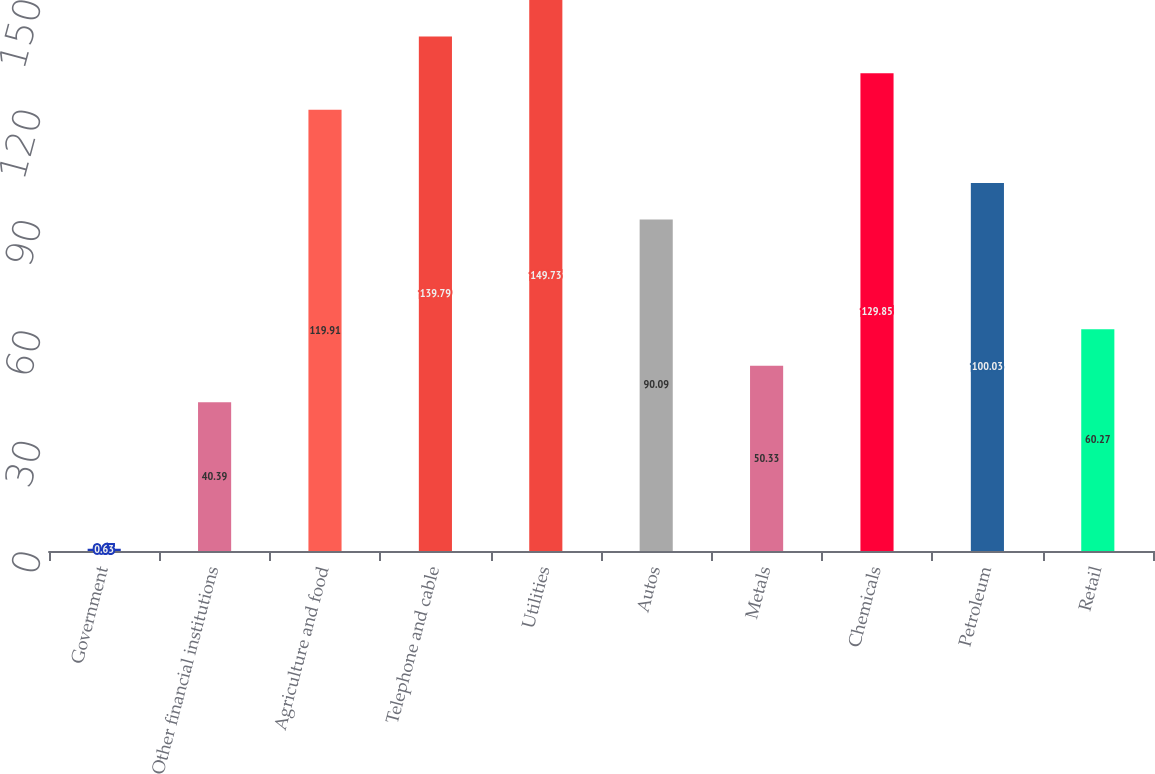Convert chart. <chart><loc_0><loc_0><loc_500><loc_500><bar_chart><fcel>Government<fcel>Other financial institutions<fcel>Agriculture and food<fcel>Telephone and cable<fcel>Utilities<fcel>Autos<fcel>Metals<fcel>Chemicals<fcel>Petroleum<fcel>Retail<nl><fcel>0.63<fcel>40.39<fcel>119.91<fcel>139.79<fcel>149.73<fcel>90.09<fcel>50.33<fcel>129.85<fcel>100.03<fcel>60.27<nl></chart> 